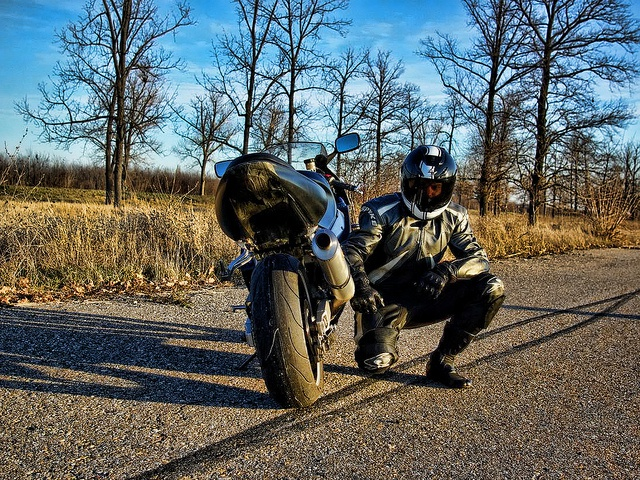Describe the objects in this image and their specific colors. I can see motorcycle in teal, black, olive, gray, and tan tones and people in teal, black, gray, olive, and tan tones in this image. 